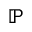<formula> <loc_0><loc_0><loc_500><loc_500>\mathbb { P }</formula> 